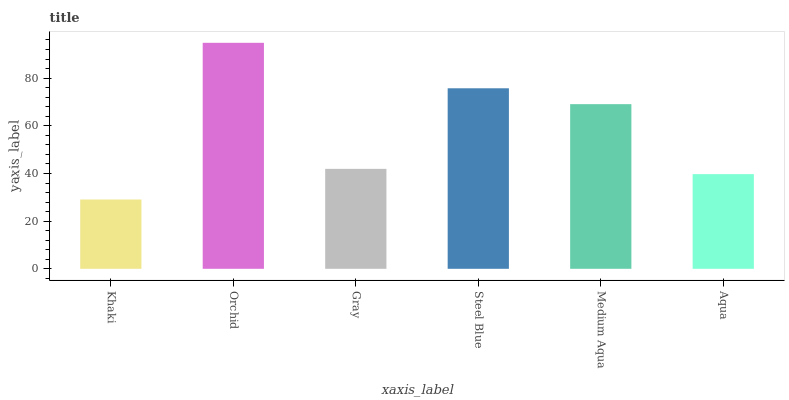Is Khaki the minimum?
Answer yes or no. Yes. Is Orchid the maximum?
Answer yes or no. Yes. Is Gray the minimum?
Answer yes or no. No. Is Gray the maximum?
Answer yes or no. No. Is Orchid greater than Gray?
Answer yes or no. Yes. Is Gray less than Orchid?
Answer yes or no. Yes. Is Gray greater than Orchid?
Answer yes or no. No. Is Orchid less than Gray?
Answer yes or no. No. Is Medium Aqua the high median?
Answer yes or no. Yes. Is Gray the low median?
Answer yes or no. Yes. Is Gray the high median?
Answer yes or no. No. Is Steel Blue the low median?
Answer yes or no. No. 